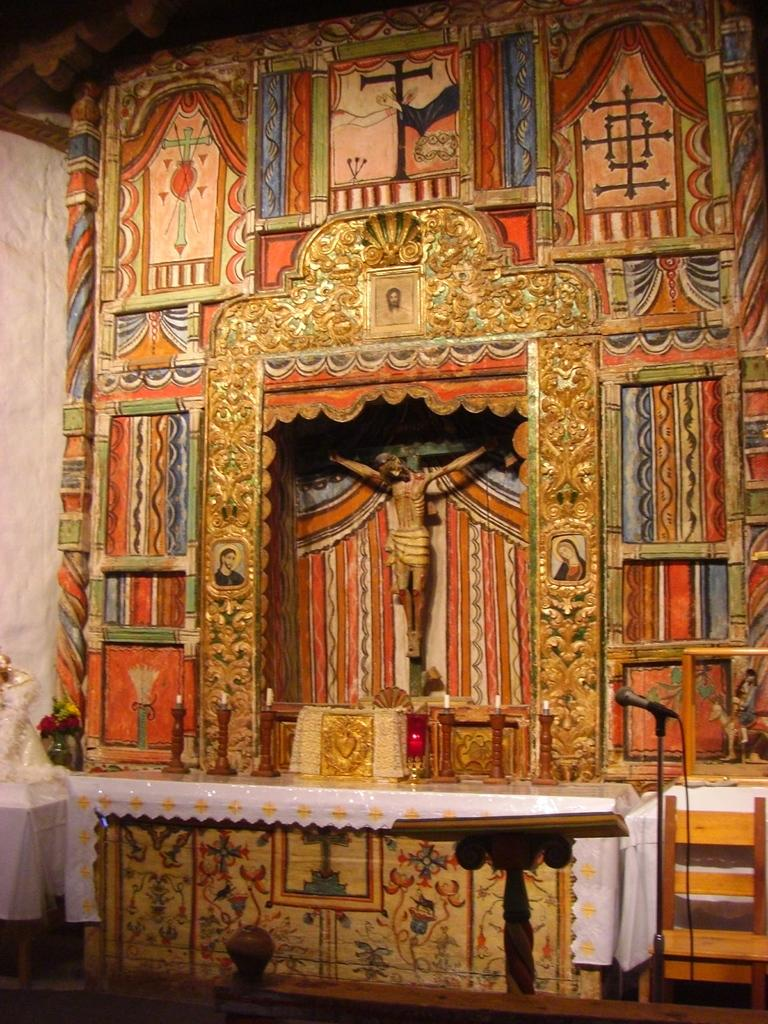What is the main structure in the image? There is a stand in the image. What can be seen on the left side of the stand? A microphone is present on the left side of the image. What other piece of furniture is visible in the image? There is a table in the image. What decorative items are on the table? Candles are on the table, and there is a sculpture at the back of the table. What type of wood is the carpenter using to create the sculpture in the image? There is no carpenter present in the image, and the sculpture's material cannot be determined from the image. How does the mind of the person holding the microphone appear in the image? The image does not show the person holding the microphone's mind, as it is not visible. 